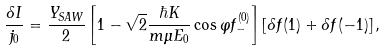<formula> <loc_0><loc_0><loc_500><loc_500>\frac { \delta I } { j _ { 0 } } = \frac { Y _ { S A W } } { 2 } \left [ 1 - \sqrt { 2 } \frac { \hbar { K } } { m \mu E _ { 0 } } \cos \varphi f _ { - } ^ { ( 0 ) } \right ] \left [ \delta f ( 1 ) + \delta f ( - 1 ) \right ] ,</formula> 